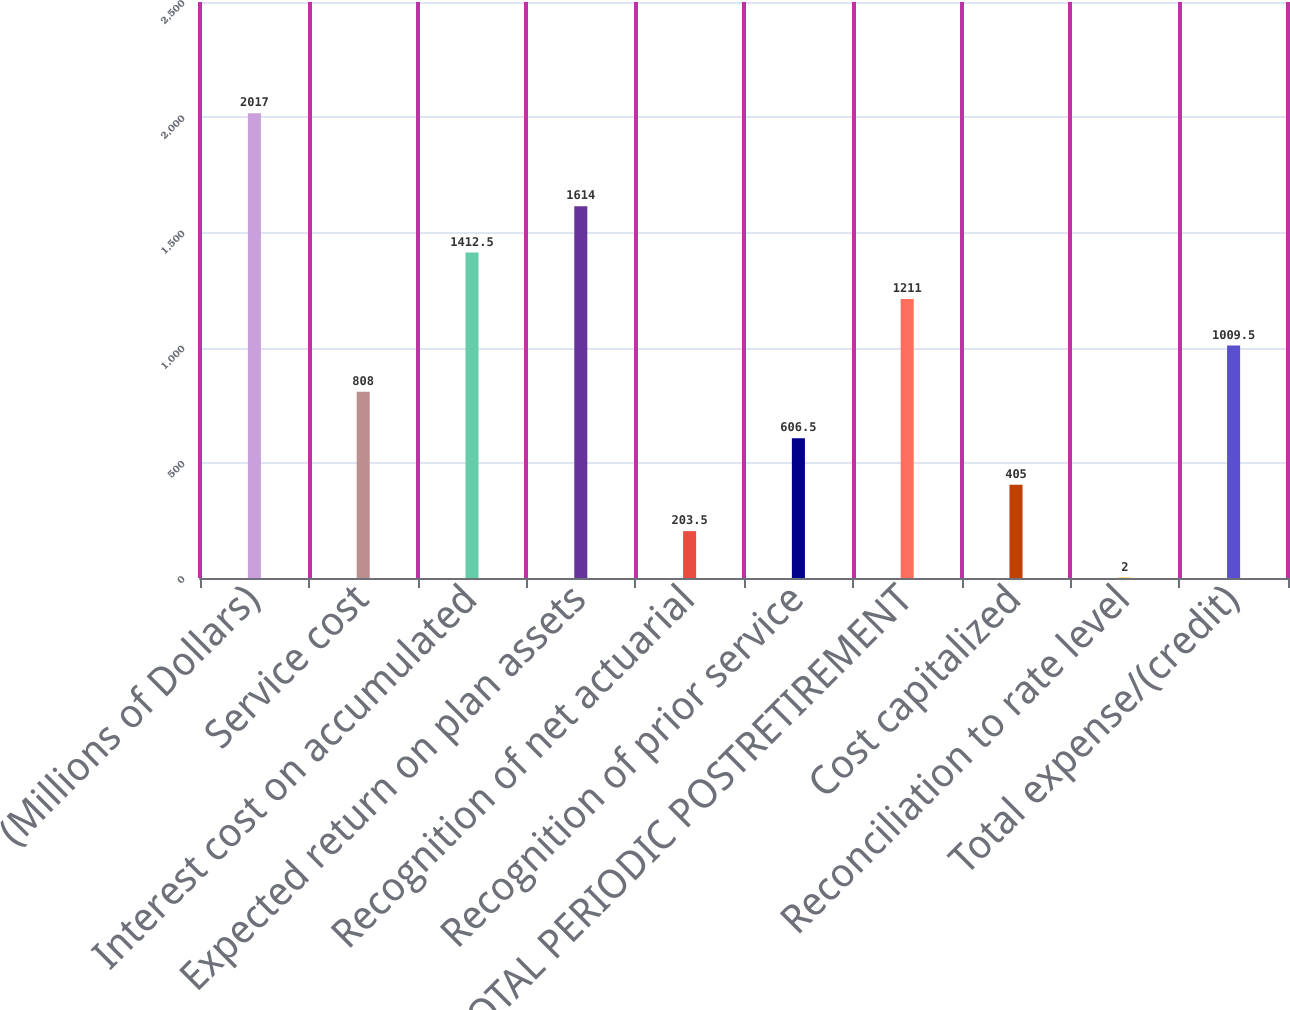Convert chart to OTSL. <chart><loc_0><loc_0><loc_500><loc_500><bar_chart><fcel>(Millions of Dollars)<fcel>Service cost<fcel>Interest cost on accumulated<fcel>Expected return on plan assets<fcel>Recognition of net actuarial<fcel>Recognition of prior service<fcel>TOTAL PERIODIC POSTRETIREMENT<fcel>Cost capitalized<fcel>Reconciliation to rate level<fcel>Total expense/(credit)<nl><fcel>2017<fcel>808<fcel>1412.5<fcel>1614<fcel>203.5<fcel>606.5<fcel>1211<fcel>405<fcel>2<fcel>1009.5<nl></chart> 